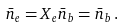Convert formula to latex. <formula><loc_0><loc_0><loc_500><loc_500>\bar { n } _ { e } = X _ { e } \bar { n } _ { b } = \bar { n } _ { b } \, .</formula> 